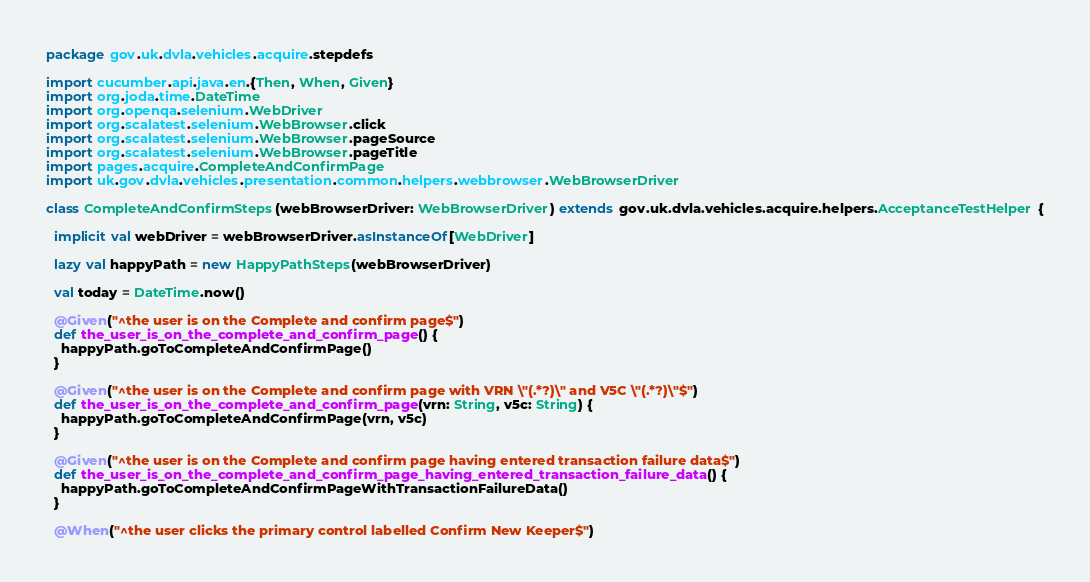Convert code to text. <code><loc_0><loc_0><loc_500><loc_500><_Scala_>package gov.uk.dvla.vehicles.acquire.stepdefs

import cucumber.api.java.en.{Then, When, Given}
import org.joda.time.DateTime
import org.openqa.selenium.WebDriver
import org.scalatest.selenium.WebBrowser.click
import org.scalatest.selenium.WebBrowser.pageSource
import org.scalatest.selenium.WebBrowser.pageTitle
import pages.acquire.CompleteAndConfirmPage
import uk.gov.dvla.vehicles.presentation.common.helpers.webbrowser.WebBrowserDriver

class CompleteAndConfirmSteps(webBrowserDriver: WebBrowserDriver) extends gov.uk.dvla.vehicles.acquire.helpers.AcceptanceTestHelper {

  implicit val webDriver = webBrowserDriver.asInstanceOf[WebDriver]

  lazy val happyPath = new HappyPathSteps(webBrowserDriver)

  val today = DateTime.now()

  @Given("^the user is on the Complete and confirm page$")
  def the_user_is_on_the_complete_and_confirm_page() {
    happyPath.goToCompleteAndConfirmPage()
  }

  @Given("^the user is on the Complete and confirm page with VRN \"(.*?)\" and V5C \"(.*?)\"$")
  def the_user_is_on_the_complete_and_confirm_page(vrn: String, v5c: String) {
    happyPath.goToCompleteAndConfirmPage(vrn, v5c)
  }

  @Given("^the user is on the Complete and confirm page having entered transaction failure data$")
  def the_user_is_on_the_complete_and_confirm_page_having_entered_transaction_failure_data() {
    happyPath.goToCompleteAndConfirmPageWithTransactionFailureData()
  }

  @When("^the user clicks the primary control labelled Confirm New Keeper$")</code> 